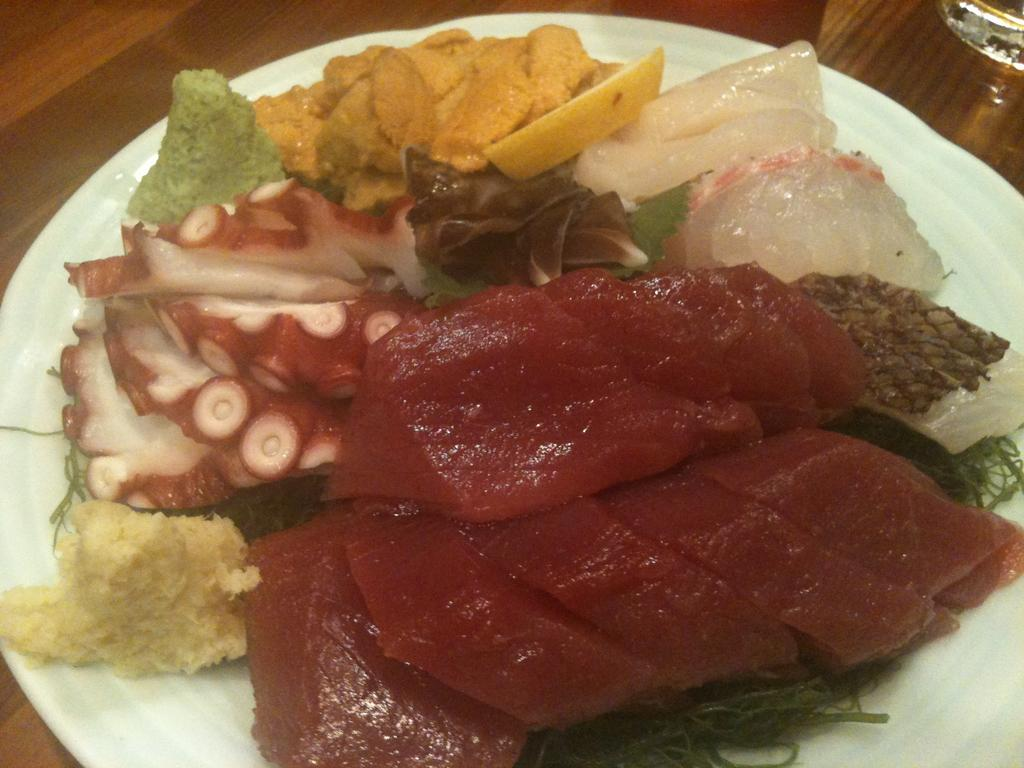What type of food is on the plate in the image? There is a plate with different varieties of meat in the image. What is the glass used for in the image? The glass is likely used for holding a beverage. Where are the plate and glass located in the image? The plate and glass are on a table in the image. What theory is being discussed by the grandmother in the image? There is no grandmother or discussion of a theory present in the image. How much growth has the plant experienced since the last time it was photographed in the image? There is no plant or indication of growth in the image. 